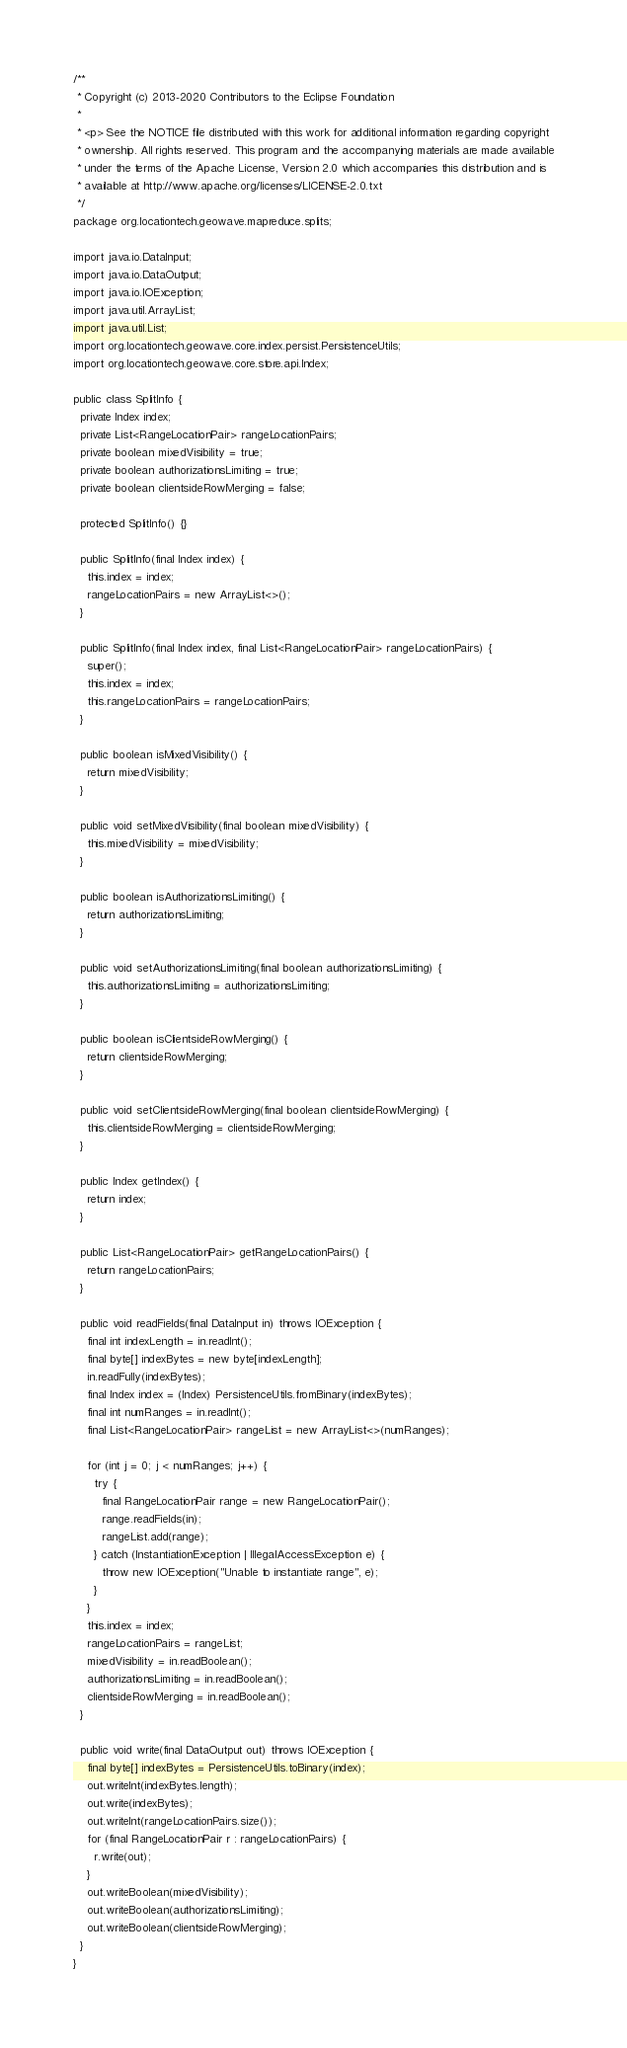<code> <loc_0><loc_0><loc_500><loc_500><_Java_>/**
 * Copyright (c) 2013-2020 Contributors to the Eclipse Foundation
 *
 * <p> See the NOTICE file distributed with this work for additional information regarding copyright
 * ownership. All rights reserved. This program and the accompanying materials are made available
 * under the terms of the Apache License, Version 2.0 which accompanies this distribution and is
 * available at http://www.apache.org/licenses/LICENSE-2.0.txt
 */
package org.locationtech.geowave.mapreduce.splits;

import java.io.DataInput;
import java.io.DataOutput;
import java.io.IOException;
import java.util.ArrayList;
import java.util.List;
import org.locationtech.geowave.core.index.persist.PersistenceUtils;
import org.locationtech.geowave.core.store.api.Index;

public class SplitInfo {
  private Index index;
  private List<RangeLocationPair> rangeLocationPairs;
  private boolean mixedVisibility = true;
  private boolean authorizationsLimiting = true;
  private boolean clientsideRowMerging = false;

  protected SplitInfo() {}

  public SplitInfo(final Index index) {
    this.index = index;
    rangeLocationPairs = new ArrayList<>();
  }

  public SplitInfo(final Index index, final List<RangeLocationPair> rangeLocationPairs) {
    super();
    this.index = index;
    this.rangeLocationPairs = rangeLocationPairs;
  }

  public boolean isMixedVisibility() {
    return mixedVisibility;
  }

  public void setMixedVisibility(final boolean mixedVisibility) {
    this.mixedVisibility = mixedVisibility;
  }

  public boolean isAuthorizationsLimiting() {
    return authorizationsLimiting;
  }

  public void setAuthorizationsLimiting(final boolean authorizationsLimiting) {
    this.authorizationsLimiting = authorizationsLimiting;
  }

  public boolean isClientsideRowMerging() {
    return clientsideRowMerging;
  }

  public void setClientsideRowMerging(final boolean clientsideRowMerging) {
    this.clientsideRowMerging = clientsideRowMerging;
  }

  public Index getIndex() {
    return index;
  }

  public List<RangeLocationPair> getRangeLocationPairs() {
    return rangeLocationPairs;
  }

  public void readFields(final DataInput in) throws IOException {
    final int indexLength = in.readInt();
    final byte[] indexBytes = new byte[indexLength];
    in.readFully(indexBytes);
    final Index index = (Index) PersistenceUtils.fromBinary(indexBytes);
    final int numRanges = in.readInt();
    final List<RangeLocationPair> rangeList = new ArrayList<>(numRanges);

    for (int j = 0; j < numRanges; j++) {
      try {
        final RangeLocationPair range = new RangeLocationPair();
        range.readFields(in);
        rangeList.add(range);
      } catch (InstantiationException | IllegalAccessException e) {
        throw new IOException("Unable to instantiate range", e);
      }
    }
    this.index = index;
    rangeLocationPairs = rangeList;
    mixedVisibility = in.readBoolean();
    authorizationsLimiting = in.readBoolean();
    clientsideRowMerging = in.readBoolean();
  }

  public void write(final DataOutput out) throws IOException {
    final byte[] indexBytes = PersistenceUtils.toBinary(index);
    out.writeInt(indexBytes.length);
    out.write(indexBytes);
    out.writeInt(rangeLocationPairs.size());
    for (final RangeLocationPair r : rangeLocationPairs) {
      r.write(out);
    }
    out.writeBoolean(mixedVisibility);
    out.writeBoolean(authorizationsLimiting);
    out.writeBoolean(clientsideRowMerging);
  }
}
</code> 